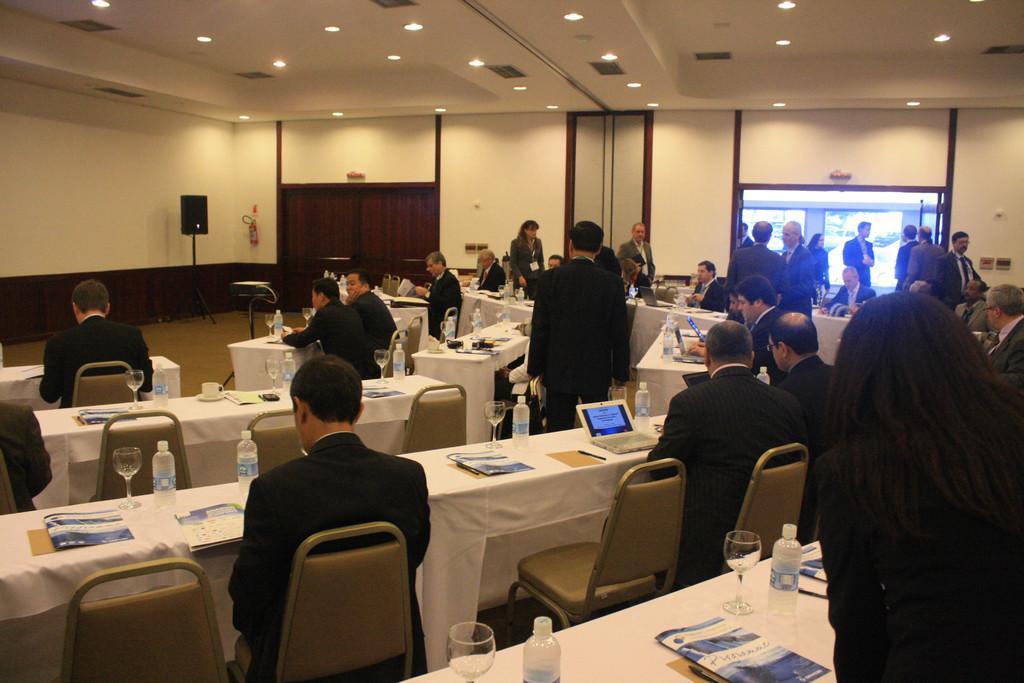Can you describe this image briefly? This is the picture of a room in which there are some people sitting on the chairs in front of the tables on which there are some bottles, glasses, screens and some other things and also we can see some lights to the roof. 